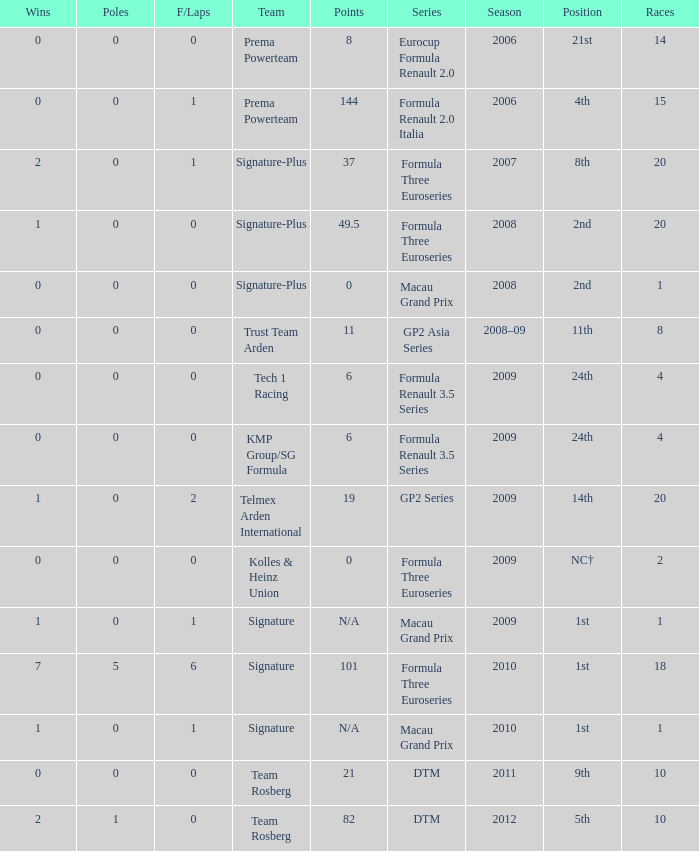How many poles are there in the Formula Three Euroseries in the 2008 season with more than 0 F/Laps? None. 